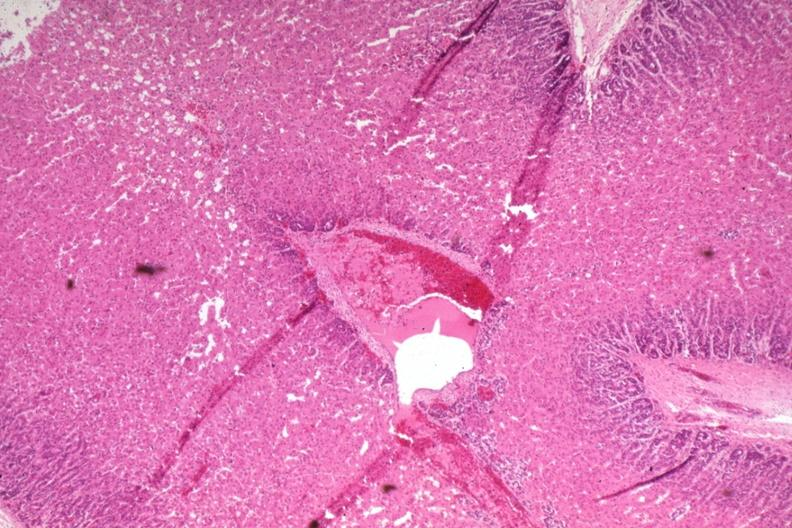s artery present?
Answer the question using a single word or phrase. No 